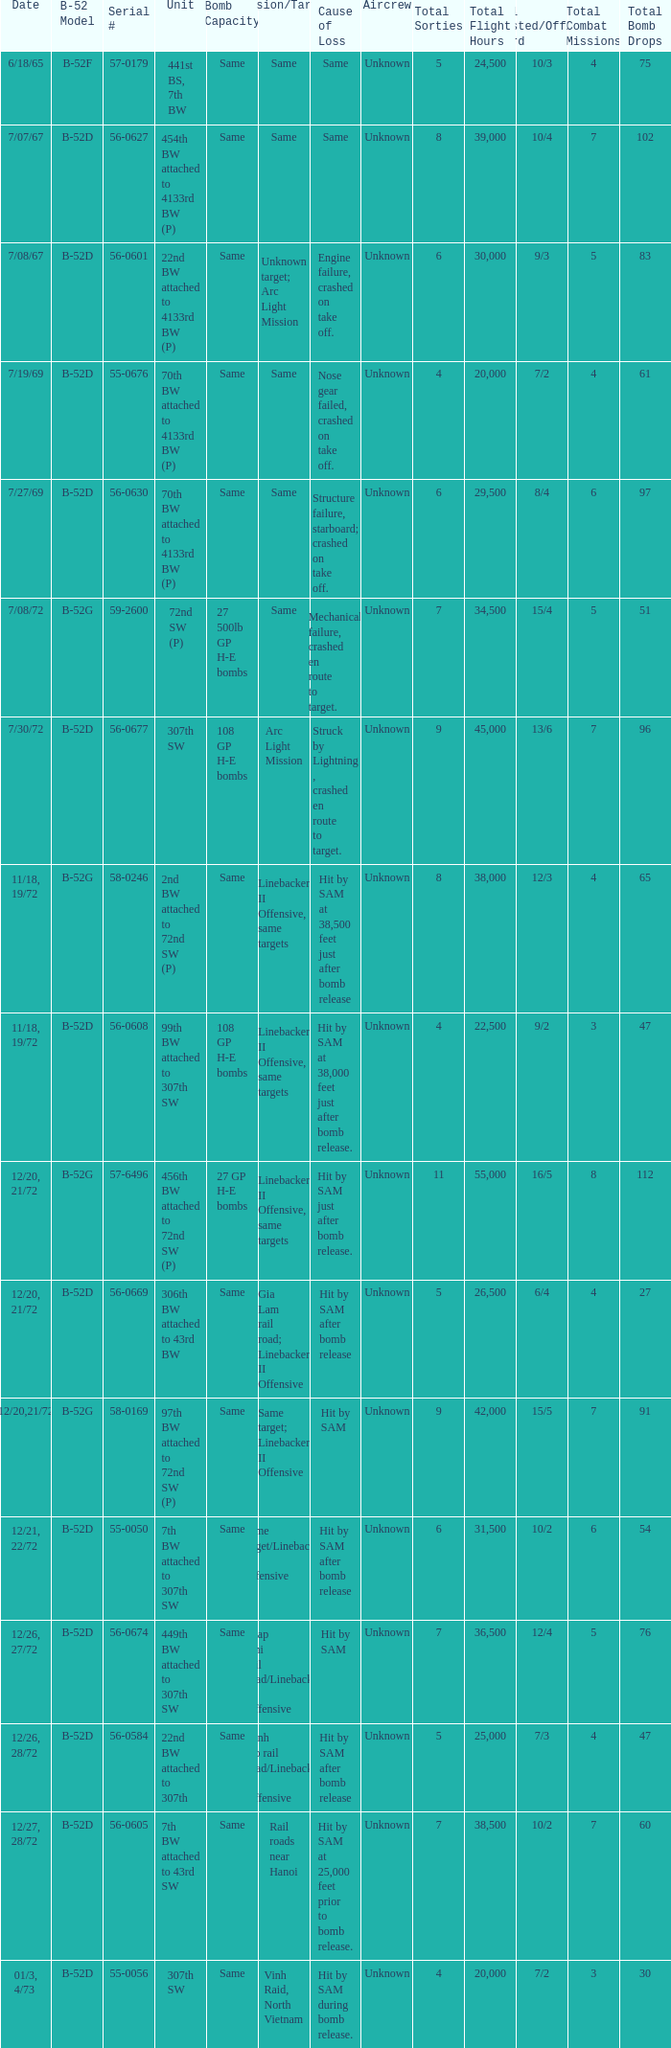When  same target; linebacker ii offensive is the same target what is the unit? 97th BW attached to 72nd SW (P). 